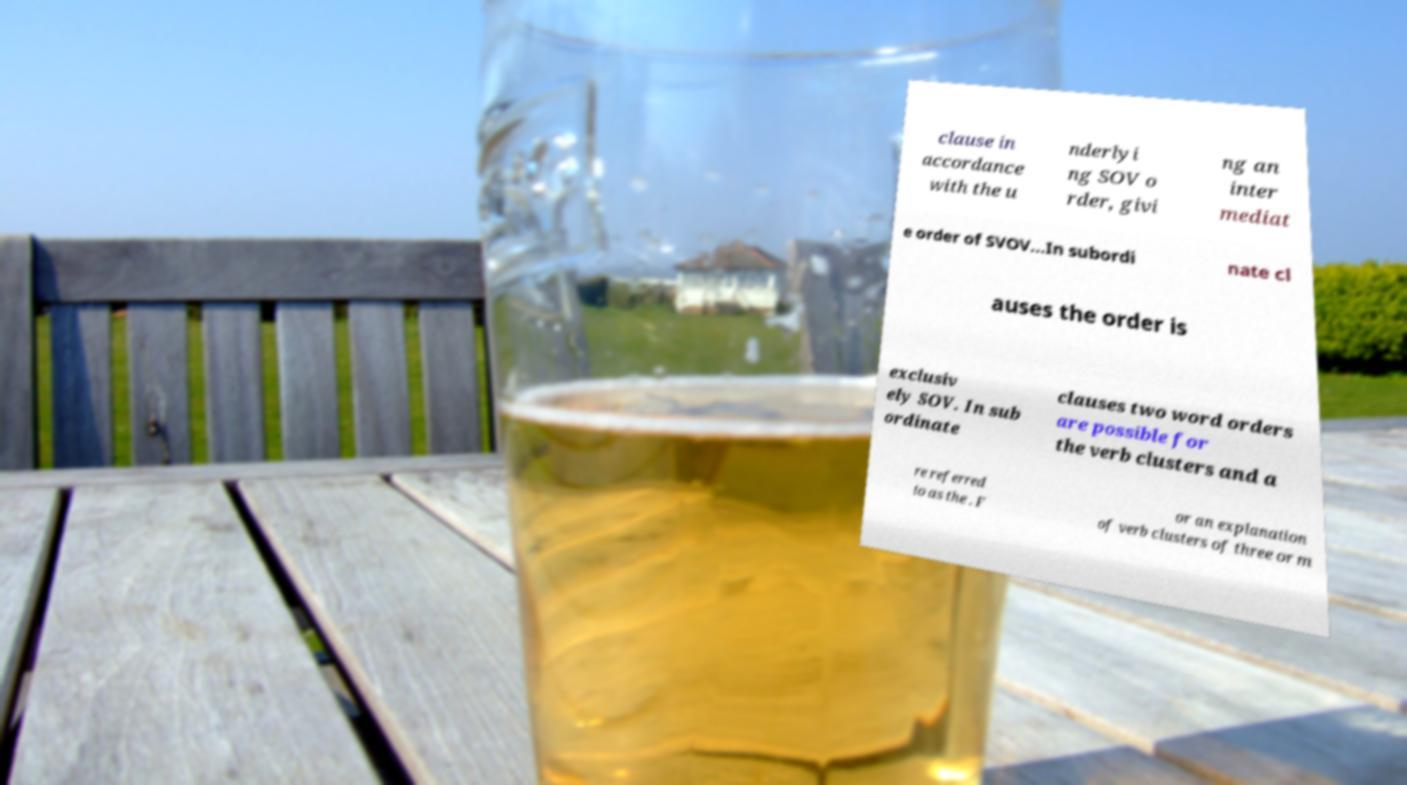What messages or text are displayed in this image? I need them in a readable, typed format. clause in accordance with the u nderlyi ng SOV o rder, givi ng an inter mediat e order of SVOV...In subordi nate cl auses the order is exclusiv ely SOV. In sub ordinate clauses two word orders are possible for the verb clusters and a re referred to as the . F or an explanation of verb clusters of three or m 